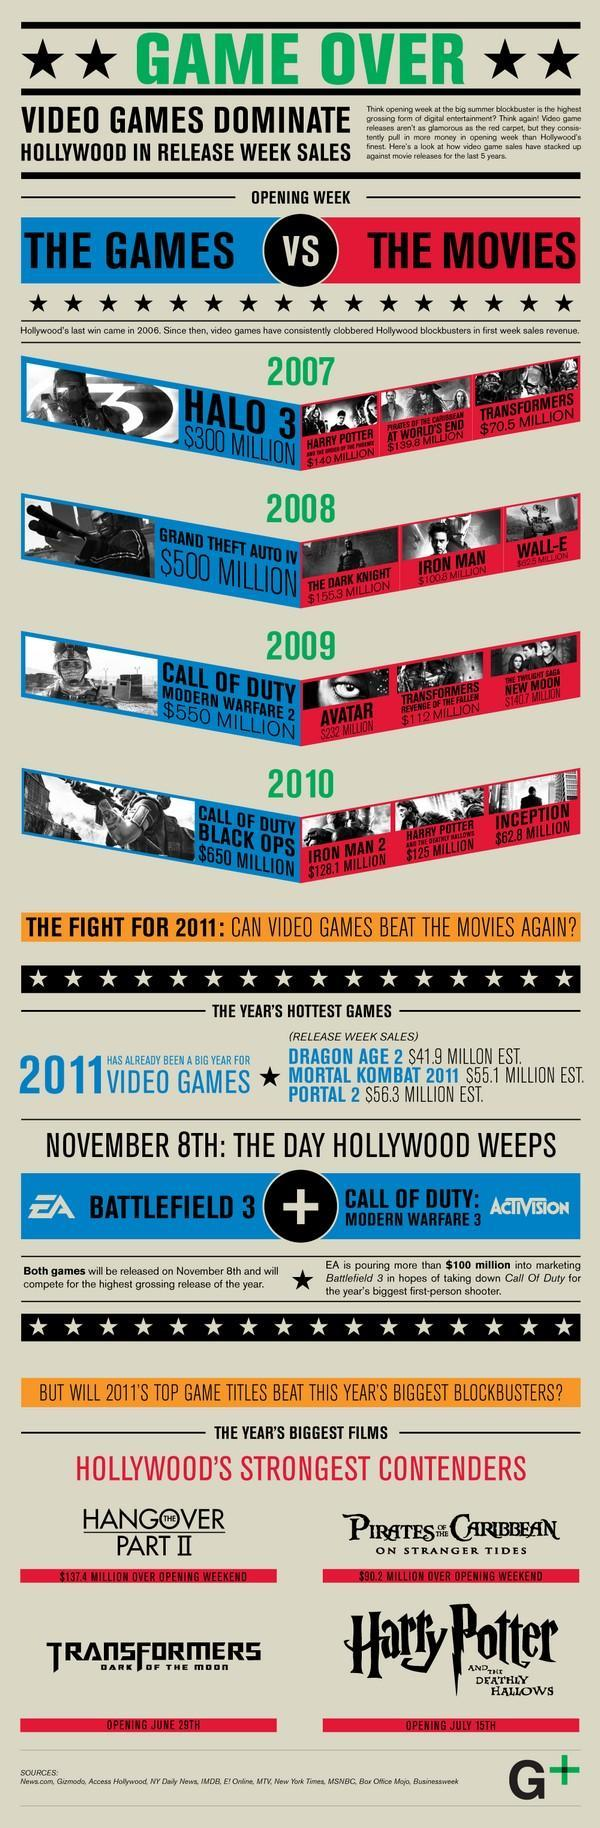When is Harry Potter and the deathly hallows opening
Answer the question with a short phrase. July 15th What has been teh sales revenue of Harry Potter in 2007 in the first week of release $140 Million WHen was Iron Man Released 2008 which year were different versions of the call of duty game released 2009, 2010 Against which game first week release sale is the Iron Man sales being compared in 2008 grand theft auto IV How many stars after Game Over 2 How much higher was the first week revenue in million dollars from Halo 3 when compared to Transformers 229.5 